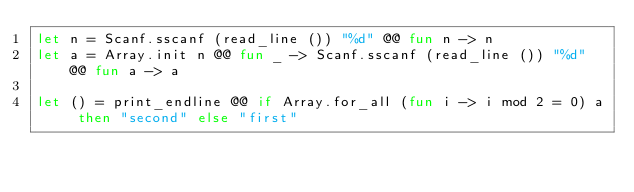Convert code to text. <code><loc_0><loc_0><loc_500><loc_500><_OCaml_>let n = Scanf.sscanf (read_line ()) "%d" @@ fun n -> n
let a = Array.init n @@ fun _ -> Scanf.sscanf (read_line ()) "%d" @@ fun a -> a

let () = print_endline @@ if Array.for_all (fun i -> i mod 2 = 0) a then "second" else "first"</code> 